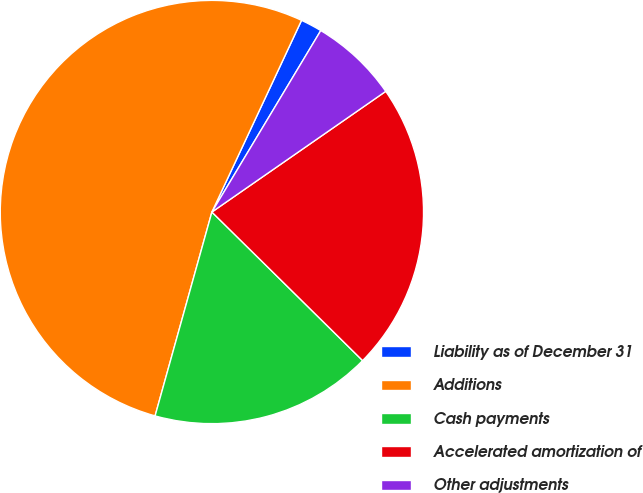Convert chart. <chart><loc_0><loc_0><loc_500><loc_500><pie_chart><fcel>Liability as of December 31<fcel>Additions<fcel>Cash payments<fcel>Accelerated amortization of<fcel>Other adjustments<nl><fcel>1.64%<fcel>52.63%<fcel>16.94%<fcel>22.04%<fcel>6.74%<nl></chart> 